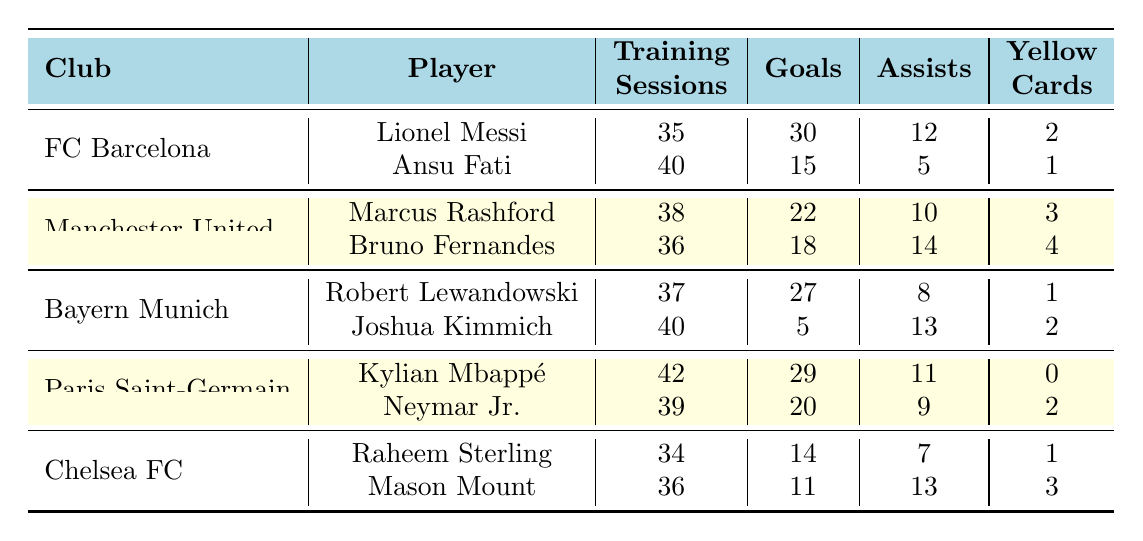What is the total number of goals scored by players from Paris Saint-Germain? Kylian Mbappé scored 29 goals and Neymar Jr. scored 20 goals. Adding these together gives 29 + 20 = 49 goals in total.
Answer: 49 Which player attended the most training sessions? Ansu Fati attended 40 training sessions, as did Joshua Kimmich; hence, the highest attendance is 40. No player attended more than this.
Answer: 40 Did Robert Lewandowski receive more yellow cards than Lionel Messi? Robert Lewandowski received 1 yellow card while Lionel Messi received 2. Therefore, Lewandowski received fewer yellow cards than Messi.
Answer: No What is the average number of assists for players in Chelsea FC? Raheem Sterling had 7 assists and Mason Mount had 13 assists. The average is calculated as (7 + 13) / 2 = 10.
Answer: 10 Who scored the least number of goals among all players? Joshua Kimmich scored 5 goals, which is less than any other player's goal tally.
Answer: 5 What is the difference in training sessions attended between players at FC Barcelona? Ansu Fati attended 40 sessions while Lionel Messi attended 35 sessions, so the difference is 40 - 35 = 5 sessions.
Answer: 5 Is Neymar Jr. a player who has scored more goals than assists? Neymar Jr. scored 20 goals and made 9 assists. Since 20 is greater than 9, the statement is true.
Answer: Yes What is the total number of yellow cards for all players from Bayern Munich? Robert Lewandowski received 1 yellow card and Joshua Kimmich received 2. Adding these gives a total of 1 + 2 = 3 yellow cards.
Answer: 3 Which club has players that attended the majority of training sessions? Paris Saint-Germain has Kylian Mbappé with 42 training sessions attended, which is the highest compared to other clubs.
Answer: Paris Saint-Germain What is the combined total of goals scored by players in Manchester United? Marcus Rashford scored 22 goals and Bruno Fernandes scored 18 goals, so the total is 22 + 18 = 40 goals.
Answer: 40 